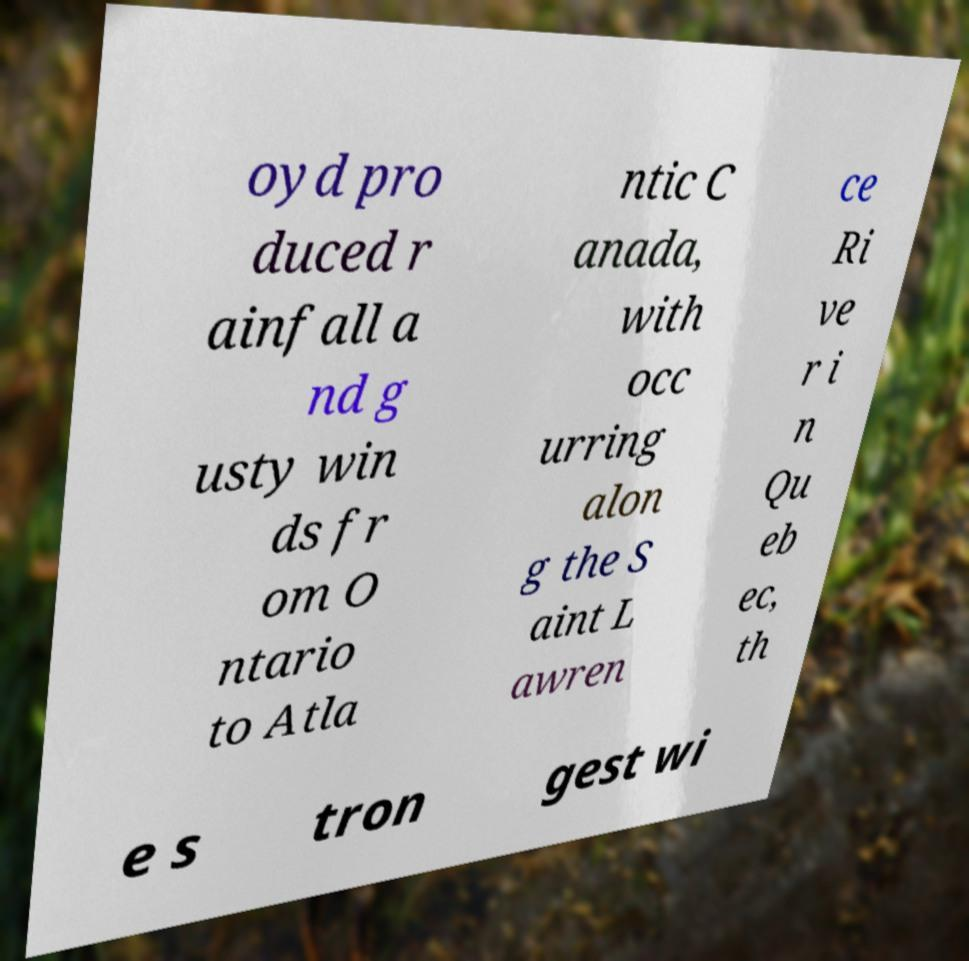There's text embedded in this image that I need extracted. Can you transcribe it verbatim? oyd pro duced r ainfall a nd g usty win ds fr om O ntario to Atla ntic C anada, with occ urring alon g the S aint L awren ce Ri ve r i n Qu eb ec, th e s tron gest wi 